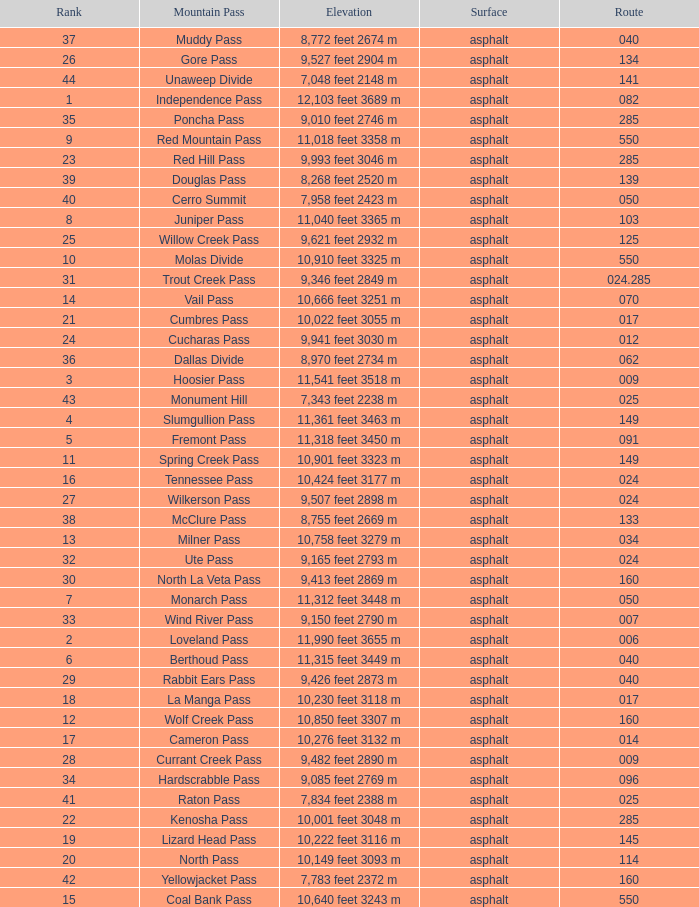Help me parse the entirety of this table. {'header': ['Rank', 'Mountain Pass', 'Elevation', 'Surface', 'Route'], 'rows': [['37', 'Muddy Pass', '8,772 feet 2674 m', 'asphalt', '040'], ['26', 'Gore Pass', '9,527 feet 2904 m', 'asphalt', '134'], ['44', 'Unaweep Divide', '7,048 feet 2148 m', 'asphalt', '141'], ['1', 'Independence Pass', '12,103 feet 3689 m', 'asphalt', '082'], ['35', 'Poncha Pass', '9,010 feet 2746 m', 'asphalt', '285'], ['9', 'Red Mountain Pass', '11,018 feet 3358 m', 'asphalt', '550'], ['23', 'Red Hill Pass', '9,993 feet 3046 m', 'asphalt', '285'], ['39', 'Douglas Pass', '8,268 feet 2520 m', 'asphalt', '139'], ['40', 'Cerro Summit', '7,958 feet 2423 m', 'asphalt', '050'], ['8', 'Juniper Pass', '11,040 feet 3365 m', 'asphalt', '103'], ['25', 'Willow Creek Pass', '9,621 feet 2932 m', 'asphalt', '125'], ['10', 'Molas Divide', '10,910 feet 3325 m', 'asphalt', '550'], ['31', 'Trout Creek Pass', '9,346 feet 2849 m', 'asphalt', '024.285'], ['14', 'Vail Pass', '10,666 feet 3251 m', 'asphalt', '070'], ['21', 'Cumbres Pass', '10,022 feet 3055 m', 'asphalt', '017'], ['24', 'Cucharas Pass', '9,941 feet 3030 m', 'asphalt', '012'], ['36', 'Dallas Divide', '8,970 feet 2734 m', 'asphalt', '062'], ['3', 'Hoosier Pass', '11,541 feet 3518 m', 'asphalt', '009'], ['43', 'Monument Hill', '7,343 feet 2238 m', 'asphalt', '025'], ['4', 'Slumgullion Pass', '11,361 feet 3463 m', 'asphalt', '149'], ['5', 'Fremont Pass', '11,318 feet 3450 m', 'asphalt', '091'], ['11', 'Spring Creek Pass', '10,901 feet 3323 m', 'asphalt', '149'], ['16', 'Tennessee Pass', '10,424 feet 3177 m', 'asphalt', '024'], ['27', 'Wilkerson Pass', '9,507 feet 2898 m', 'asphalt', '024'], ['38', 'McClure Pass', '8,755 feet 2669 m', 'asphalt', '133'], ['13', 'Milner Pass', '10,758 feet 3279 m', 'asphalt', '034'], ['32', 'Ute Pass', '9,165 feet 2793 m', 'asphalt', '024'], ['30', 'North La Veta Pass', '9,413 feet 2869 m', 'asphalt', '160'], ['7', 'Monarch Pass', '11,312 feet 3448 m', 'asphalt', '050'], ['33', 'Wind River Pass', '9,150 feet 2790 m', 'asphalt', '007'], ['2', 'Loveland Pass', '11,990 feet 3655 m', 'asphalt', '006'], ['6', 'Berthoud Pass', '11,315 feet 3449 m', 'asphalt', '040'], ['29', 'Rabbit Ears Pass', '9,426 feet 2873 m', 'asphalt', '040'], ['18', 'La Manga Pass', '10,230 feet 3118 m', 'asphalt', '017'], ['12', 'Wolf Creek Pass', '10,850 feet 3307 m', 'asphalt', '160'], ['17', 'Cameron Pass', '10,276 feet 3132 m', 'asphalt', '014'], ['28', 'Currant Creek Pass', '9,482 feet 2890 m', 'asphalt', '009'], ['34', 'Hardscrabble Pass', '9,085 feet 2769 m', 'asphalt', '096'], ['41', 'Raton Pass', '7,834 feet 2388 m', 'asphalt', '025'], ['22', 'Kenosha Pass', '10,001 feet 3048 m', 'asphalt', '285'], ['19', 'Lizard Head Pass', '10,222 feet 3116 m', 'asphalt', '145'], ['20', 'North Pass', '10,149 feet 3093 m', 'asphalt', '114'], ['42', 'Yellowjacket Pass', '7,783 feet 2372 m', 'asphalt', '160'], ['15', 'Coal Bank Pass', '10,640 feet 3243 m', 'asphalt', '550']]} What is the Mountain Pass with a 21 Rank? Cumbres Pass. 